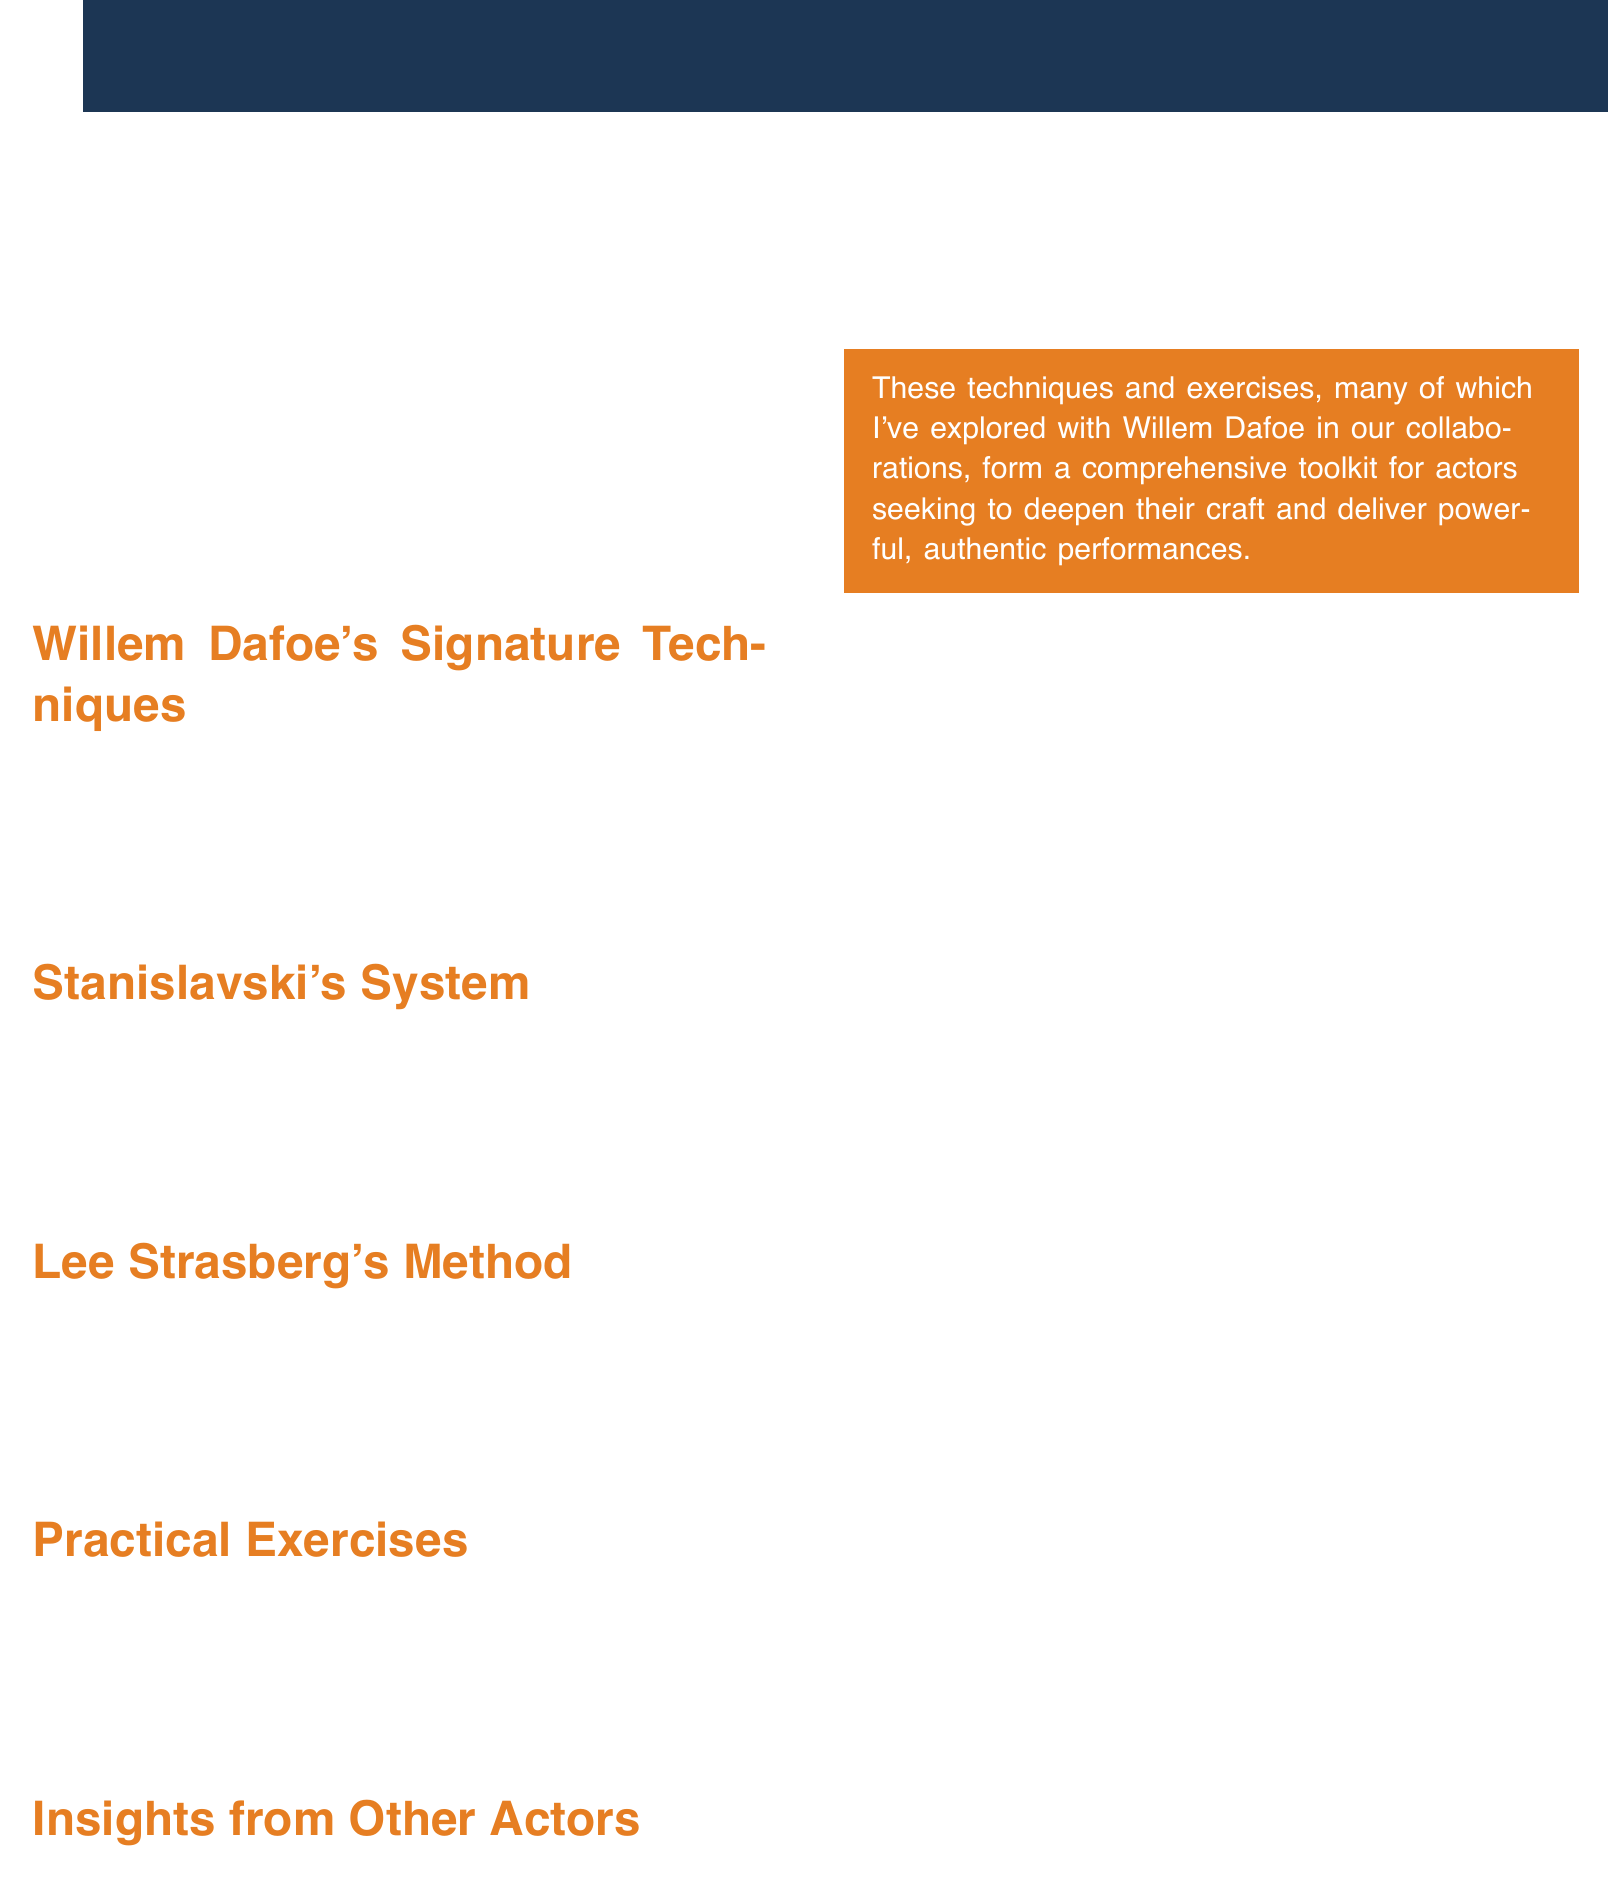What is the title of the document? The title is presented at the top of the document, which is "Method Acting Mastery."
Answer: Method Acting Mastery Who is the featured actor alongside Willem Dafoe? The document mentions several actors, but one is specifically indicated as providing insights, which is Daniel Day-Lewis.
Answer: Daniel Day-Lewis What is one of Willem Dafoe's signature techniques? The document lists various techniques, one of which is "Emotional Memory Recall."
Answer: Emotional Memory Recall Which method includes "The 'Magic If'"? "The 'Magic If'" is part of Stanislavski's System, as outlined in the document.
Answer: Stanislavski's System What exercise is associated with Lee Strasberg's Method? The document lists multiple exercises, one being "Relaxation Exercises."
Answer: Relaxation Exercises What type of analysis is mentioned in the Practical Exercises section? The document indicates Laban Movement Analysis as part of the practical exercises.
Answer: Laban Movement Analysis Which technique focuses on total immersion? The document attributes total immersion to the insights of Daniel Day-Lewis.
Answer: Total immersion What color is used for the title text? The document specifies the color of the title text as white.
Answer: white 